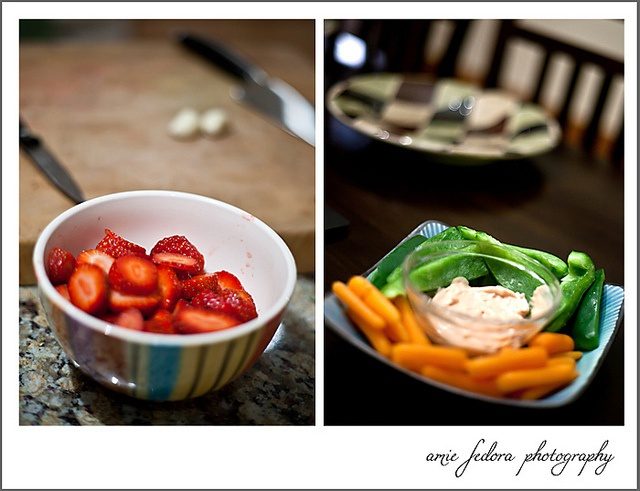Describe the objects in this image and their specific colors. I can see bowl in gray, lightgray, brown, maroon, and olive tones, dining table in gray, black, darkgray, and white tones, bowl in gray, red, orange, black, and brown tones, dining table in gray, black, and darkgray tones, and bowl in gray, ivory, tan, and green tones in this image. 